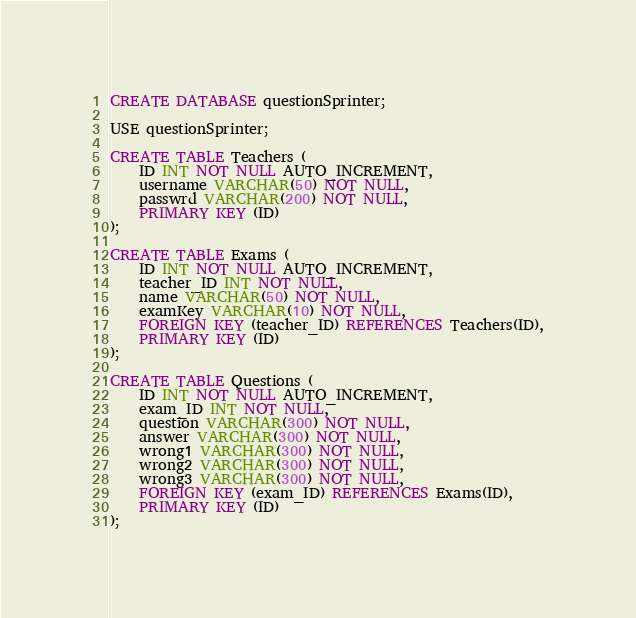<code> <loc_0><loc_0><loc_500><loc_500><_SQL_>CREATE DATABASE questionSprinter;

USE questionSprinter;

CREATE TABLE Teachers (
	ID INT NOT NULL AUTO_INCREMENT,
	username VARCHAR(50) NOT NULL,
	passwrd VARCHAR(200) NOT NULL,
	PRIMARY KEY (ID)
);

CREATE TABLE Exams (
	ID INT NOT NULL AUTO_INCREMENT,
	teacher_ID INT NOT NULL,
	name VARCHAR(50) NOT NULL,
	examKey VARCHAR(10) NOT NULL,
	FOREIGN KEY (teacher_ID) REFERENCES Teachers(ID),
	PRIMARY KEY (ID)
);

CREATE TABLE Questions (
	ID INT NOT NULL AUTO_INCREMENT,
	exam_ID INT NOT NULL,
	question VARCHAR(300) NOT NULL,
	answer VARCHAR(300) NOT NULL,
	wrong1 VARCHAR(300) NOT NULL,
	wrong2 VARCHAR(300) NOT NULL,
	wrong3 VARCHAR(300) NOT NULL,
	FOREIGN KEY (exam_ID) REFERENCES Exams(ID),
	PRIMARY KEY (ID)
);</code> 